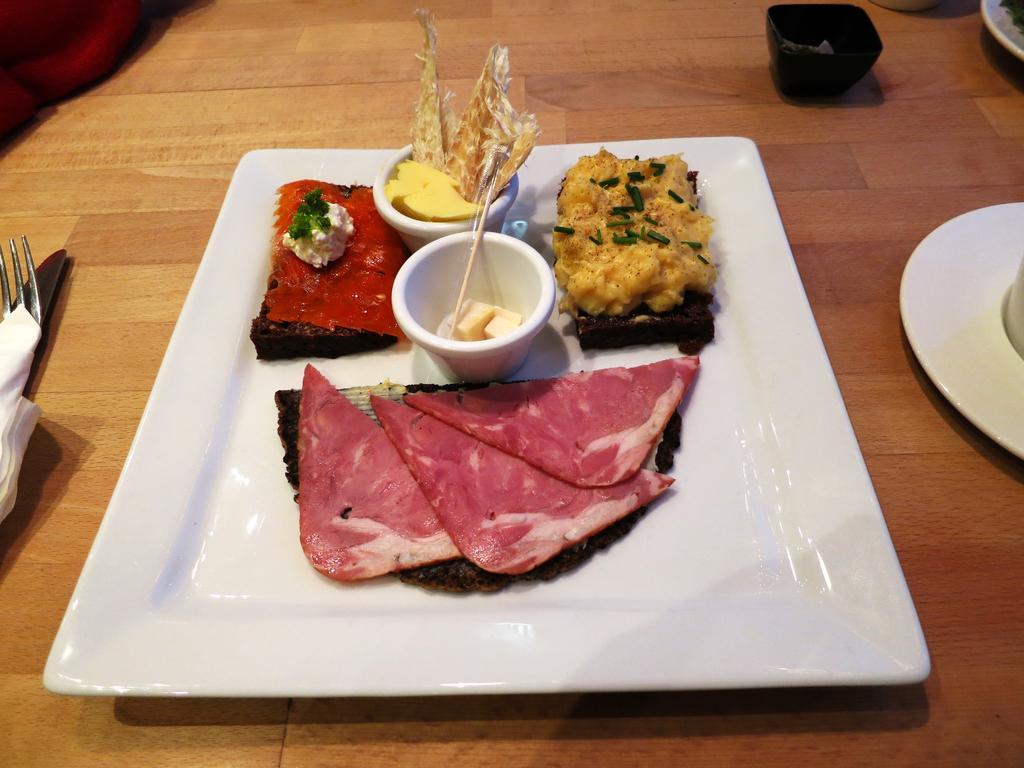Please provide a concise description of this image. There are food items in a tray in the foreground area of the image, there are plates, spoons and tissues on the table. 